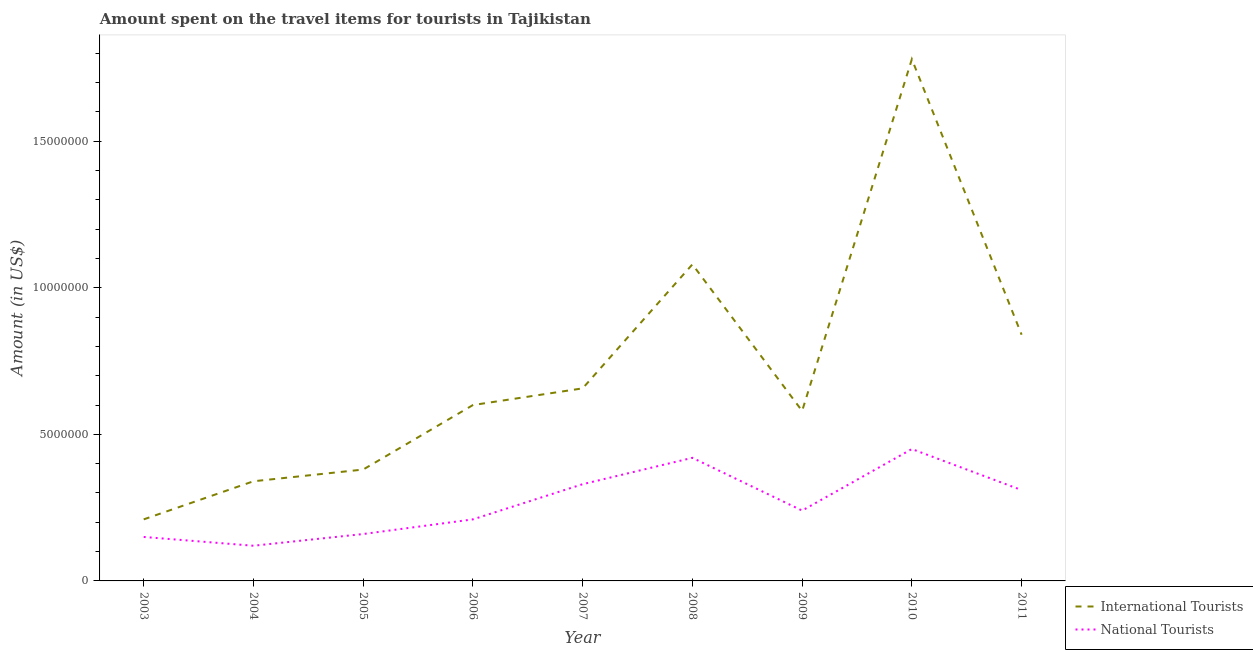Is the number of lines equal to the number of legend labels?
Your answer should be very brief. Yes. What is the amount spent on travel items of national tourists in 2004?
Provide a succinct answer. 1.20e+06. Across all years, what is the maximum amount spent on travel items of national tourists?
Provide a succinct answer. 4.50e+06. Across all years, what is the minimum amount spent on travel items of international tourists?
Offer a very short reply. 2.10e+06. In which year was the amount spent on travel items of international tourists minimum?
Give a very brief answer. 2003. What is the total amount spent on travel items of international tourists in the graph?
Give a very brief answer. 6.47e+07. What is the difference between the amount spent on travel items of international tourists in 2004 and that in 2009?
Your answer should be compact. -2.40e+06. What is the difference between the amount spent on travel items of international tourists in 2003 and the amount spent on travel items of national tourists in 2009?
Offer a terse response. -3.00e+05. What is the average amount spent on travel items of national tourists per year?
Offer a terse response. 2.66e+06. In the year 2007, what is the difference between the amount spent on travel items of national tourists and amount spent on travel items of international tourists?
Ensure brevity in your answer.  -3.27e+06. What is the ratio of the amount spent on travel items of national tourists in 2006 to that in 2010?
Keep it short and to the point. 0.47. Is the difference between the amount spent on travel items of international tourists in 2003 and 2011 greater than the difference between the amount spent on travel items of national tourists in 2003 and 2011?
Your response must be concise. No. What is the difference between the highest and the second highest amount spent on travel items of international tourists?
Your response must be concise. 7.00e+06. What is the difference between the highest and the lowest amount spent on travel items of international tourists?
Provide a succinct answer. 1.57e+07. Does the amount spent on travel items of international tourists monotonically increase over the years?
Your response must be concise. No. How many years are there in the graph?
Your response must be concise. 9. Does the graph contain grids?
Keep it short and to the point. No. How many legend labels are there?
Offer a very short reply. 2. What is the title of the graph?
Provide a short and direct response. Amount spent on the travel items for tourists in Tajikistan. What is the label or title of the X-axis?
Your answer should be very brief. Year. What is the label or title of the Y-axis?
Provide a succinct answer. Amount (in US$). What is the Amount (in US$) of International Tourists in 2003?
Keep it short and to the point. 2.10e+06. What is the Amount (in US$) in National Tourists in 2003?
Give a very brief answer. 1.50e+06. What is the Amount (in US$) of International Tourists in 2004?
Provide a short and direct response. 3.40e+06. What is the Amount (in US$) in National Tourists in 2004?
Keep it short and to the point. 1.20e+06. What is the Amount (in US$) of International Tourists in 2005?
Your answer should be very brief. 3.80e+06. What is the Amount (in US$) of National Tourists in 2005?
Your answer should be compact. 1.60e+06. What is the Amount (in US$) in National Tourists in 2006?
Provide a succinct answer. 2.10e+06. What is the Amount (in US$) in International Tourists in 2007?
Offer a terse response. 6.57e+06. What is the Amount (in US$) of National Tourists in 2007?
Your response must be concise. 3.30e+06. What is the Amount (in US$) in International Tourists in 2008?
Offer a very short reply. 1.08e+07. What is the Amount (in US$) in National Tourists in 2008?
Provide a short and direct response. 4.20e+06. What is the Amount (in US$) in International Tourists in 2009?
Offer a very short reply. 5.80e+06. What is the Amount (in US$) of National Tourists in 2009?
Give a very brief answer. 2.40e+06. What is the Amount (in US$) of International Tourists in 2010?
Provide a succinct answer. 1.78e+07. What is the Amount (in US$) in National Tourists in 2010?
Ensure brevity in your answer.  4.50e+06. What is the Amount (in US$) of International Tourists in 2011?
Offer a very short reply. 8.40e+06. What is the Amount (in US$) of National Tourists in 2011?
Your response must be concise. 3.10e+06. Across all years, what is the maximum Amount (in US$) in International Tourists?
Provide a short and direct response. 1.78e+07. Across all years, what is the maximum Amount (in US$) of National Tourists?
Your answer should be compact. 4.50e+06. Across all years, what is the minimum Amount (in US$) of International Tourists?
Your response must be concise. 2.10e+06. Across all years, what is the minimum Amount (in US$) in National Tourists?
Offer a terse response. 1.20e+06. What is the total Amount (in US$) in International Tourists in the graph?
Ensure brevity in your answer.  6.47e+07. What is the total Amount (in US$) in National Tourists in the graph?
Keep it short and to the point. 2.39e+07. What is the difference between the Amount (in US$) of International Tourists in 2003 and that in 2004?
Your answer should be very brief. -1.30e+06. What is the difference between the Amount (in US$) of International Tourists in 2003 and that in 2005?
Ensure brevity in your answer.  -1.70e+06. What is the difference between the Amount (in US$) of National Tourists in 2003 and that in 2005?
Your response must be concise. -1.00e+05. What is the difference between the Amount (in US$) in International Tourists in 2003 and that in 2006?
Give a very brief answer. -3.90e+06. What is the difference between the Amount (in US$) in National Tourists in 2003 and that in 2006?
Make the answer very short. -6.00e+05. What is the difference between the Amount (in US$) in International Tourists in 2003 and that in 2007?
Offer a terse response. -4.47e+06. What is the difference between the Amount (in US$) in National Tourists in 2003 and that in 2007?
Your answer should be compact. -1.80e+06. What is the difference between the Amount (in US$) of International Tourists in 2003 and that in 2008?
Ensure brevity in your answer.  -8.70e+06. What is the difference between the Amount (in US$) of National Tourists in 2003 and that in 2008?
Ensure brevity in your answer.  -2.70e+06. What is the difference between the Amount (in US$) in International Tourists in 2003 and that in 2009?
Give a very brief answer. -3.70e+06. What is the difference between the Amount (in US$) in National Tourists in 2003 and that in 2009?
Keep it short and to the point. -9.00e+05. What is the difference between the Amount (in US$) in International Tourists in 2003 and that in 2010?
Make the answer very short. -1.57e+07. What is the difference between the Amount (in US$) of International Tourists in 2003 and that in 2011?
Keep it short and to the point. -6.30e+06. What is the difference between the Amount (in US$) of National Tourists in 2003 and that in 2011?
Offer a terse response. -1.60e+06. What is the difference between the Amount (in US$) of International Tourists in 2004 and that in 2005?
Provide a short and direct response. -4.00e+05. What is the difference between the Amount (in US$) of National Tourists in 2004 and that in 2005?
Your answer should be very brief. -4.00e+05. What is the difference between the Amount (in US$) in International Tourists in 2004 and that in 2006?
Make the answer very short. -2.60e+06. What is the difference between the Amount (in US$) in National Tourists in 2004 and that in 2006?
Your answer should be very brief. -9.00e+05. What is the difference between the Amount (in US$) of International Tourists in 2004 and that in 2007?
Ensure brevity in your answer.  -3.17e+06. What is the difference between the Amount (in US$) in National Tourists in 2004 and that in 2007?
Offer a terse response. -2.10e+06. What is the difference between the Amount (in US$) in International Tourists in 2004 and that in 2008?
Give a very brief answer. -7.40e+06. What is the difference between the Amount (in US$) of International Tourists in 2004 and that in 2009?
Ensure brevity in your answer.  -2.40e+06. What is the difference between the Amount (in US$) of National Tourists in 2004 and that in 2009?
Ensure brevity in your answer.  -1.20e+06. What is the difference between the Amount (in US$) of International Tourists in 2004 and that in 2010?
Keep it short and to the point. -1.44e+07. What is the difference between the Amount (in US$) of National Tourists in 2004 and that in 2010?
Give a very brief answer. -3.30e+06. What is the difference between the Amount (in US$) of International Tourists in 2004 and that in 2011?
Keep it short and to the point. -5.00e+06. What is the difference between the Amount (in US$) of National Tourists in 2004 and that in 2011?
Provide a succinct answer. -1.90e+06. What is the difference between the Amount (in US$) of International Tourists in 2005 and that in 2006?
Offer a very short reply. -2.20e+06. What is the difference between the Amount (in US$) in National Tourists in 2005 and that in 2006?
Your answer should be compact. -5.00e+05. What is the difference between the Amount (in US$) in International Tourists in 2005 and that in 2007?
Keep it short and to the point. -2.77e+06. What is the difference between the Amount (in US$) in National Tourists in 2005 and that in 2007?
Offer a terse response. -1.70e+06. What is the difference between the Amount (in US$) of International Tourists in 2005 and that in 2008?
Offer a terse response. -7.00e+06. What is the difference between the Amount (in US$) of National Tourists in 2005 and that in 2008?
Your answer should be compact. -2.60e+06. What is the difference between the Amount (in US$) of International Tourists in 2005 and that in 2009?
Give a very brief answer. -2.00e+06. What is the difference between the Amount (in US$) in National Tourists in 2005 and that in 2009?
Your response must be concise. -8.00e+05. What is the difference between the Amount (in US$) of International Tourists in 2005 and that in 2010?
Offer a terse response. -1.40e+07. What is the difference between the Amount (in US$) of National Tourists in 2005 and that in 2010?
Your answer should be compact. -2.90e+06. What is the difference between the Amount (in US$) of International Tourists in 2005 and that in 2011?
Offer a terse response. -4.60e+06. What is the difference between the Amount (in US$) of National Tourists in 2005 and that in 2011?
Make the answer very short. -1.50e+06. What is the difference between the Amount (in US$) of International Tourists in 2006 and that in 2007?
Offer a terse response. -5.70e+05. What is the difference between the Amount (in US$) in National Tourists in 2006 and that in 2007?
Make the answer very short. -1.20e+06. What is the difference between the Amount (in US$) in International Tourists in 2006 and that in 2008?
Offer a very short reply. -4.80e+06. What is the difference between the Amount (in US$) in National Tourists in 2006 and that in 2008?
Make the answer very short. -2.10e+06. What is the difference between the Amount (in US$) in International Tourists in 2006 and that in 2009?
Keep it short and to the point. 2.00e+05. What is the difference between the Amount (in US$) of International Tourists in 2006 and that in 2010?
Provide a succinct answer. -1.18e+07. What is the difference between the Amount (in US$) of National Tourists in 2006 and that in 2010?
Offer a terse response. -2.40e+06. What is the difference between the Amount (in US$) of International Tourists in 2006 and that in 2011?
Give a very brief answer. -2.40e+06. What is the difference between the Amount (in US$) in International Tourists in 2007 and that in 2008?
Ensure brevity in your answer.  -4.23e+06. What is the difference between the Amount (in US$) in National Tourists in 2007 and that in 2008?
Provide a short and direct response. -9.00e+05. What is the difference between the Amount (in US$) in International Tourists in 2007 and that in 2009?
Ensure brevity in your answer.  7.70e+05. What is the difference between the Amount (in US$) of International Tourists in 2007 and that in 2010?
Provide a short and direct response. -1.12e+07. What is the difference between the Amount (in US$) in National Tourists in 2007 and that in 2010?
Your answer should be very brief. -1.20e+06. What is the difference between the Amount (in US$) of International Tourists in 2007 and that in 2011?
Ensure brevity in your answer.  -1.83e+06. What is the difference between the Amount (in US$) in National Tourists in 2007 and that in 2011?
Your response must be concise. 2.00e+05. What is the difference between the Amount (in US$) in National Tourists in 2008 and that in 2009?
Provide a succinct answer. 1.80e+06. What is the difference between the Amount (in US$) of International Tourists in 2008 and that in 2010?
Provide a succinct answer. -7.00e+06. What is the difference between the Amount (in US$) of International Tourists in 2008 and that in 2011?
Ensure brevity in your answer.  2.40e+06. What is the difference between the Amount (in US$) in National Tourists in 2008 and that in 2011?
Keep it short and to the point. 1.10e+06. What is the difference between the Amount (in US$) of International Tourists in 2009 and that in 2010?
Your answer should be compact. -1.20e+07. What is the difference between the Amount (in US$) in National Tourists in 2009 and that in 2010?
Make the answer very short. -2.10e+06. What is the difference between the Amount (in US$) of International Tourists in 2009 and that in 2011?
Your response must be concise. -2.60e+06. What is the difference between the Amount (in US$) in National Tourists in 2009 and that in 2011?
Your response must be concise. -7.00e+05. What is the difference between the Amount (in US$) in International Tourists in 2010 and that in 2011?
Keep it short and to the point. 9.40e+06. What is the difference between the Amount (in US$) in National Tourists in 2010 and that in 2011?
Your response must be concise. 1.40e+06. What is the difference between the Amount (in US$) of International Tourists in 2003 and the Amount (in US$) of National Tourists in 2004?
Give a very brief answer. 9.00e+05. What is the difference between the Amount (in US$) in International Tourists in 2003 and the Amount (in US$) in National Tourists in 2005?
Provide a succinct answer. 5.00e+05. What is the difference between the Amount (in US$) in International Tourists in 2003 and the Amount (in US$) in National Tourists in 2006?
Provide a succinct answer. 0. What is the difference between the Amount (in US$) of International Tourists in 2003 and the Amount (in US$) of National Tourists in 2007?
Keep it short and to the point. -1.20e+06. What is the difference between the Amount (in US$) in International Tourists in 2003 and the Amount (in US$) in National Tourists in 2008?
Provide a short and direct response. -2.10e+06. What is the difference between the Amount (in US$) in International Tourists in 2003 and the Amount (in US$) in National Tourists in 2009?
Your answer should be compact. -3.00e+05. What is the difference between the Amount (in US$) of International Tourists in 2003 and the Amount (in US$) of National Tourists in 2010?
Keep it short and to the point. -2.40e+06. What is the difference between the Amount (in US$) of International Tourists in 2004 and the Amount (in US$) of National Tourists in 2005?
Make the answer very short. 1.80e+06. What is the difference between the Amount (in US$) of International Tourists in 2004 and the Amount (in US$) of National Tourists in 2006?
Your answer should be very brief. 1.30e+06. What is the difference between the Amount (in US$) of International Tourists in 2004 and the Amount (in US$) of National Tourists in 2007?
Give a very brief answer. 1.00e+05. What is the difference between the Amount (in US$) in International Tourists in 2004 and the Amount (in US$) in National Tourists in 2008?
Ensure brevity in your answer.  -8.00e+05. What is the difference between the Amount (in US$) in International Tourists in 2004 and the Amount (in US$) in National Tourists in 2010?
Provide a short and direct response. -1.10e+06. What is the difference between the Amount (in US$) of International Tourists in 2005 and the Amount (in US$) of National Tourists in 2006?
Keep it short and to the point. 1.70e+06. What is the difference between the Amount (in US$) in International Tourists in 2005 and the Amount (in US$) in National Tourists in 2008?
Ensure brevity in your answer.  -4.00e+05. What is the difference between the Amount (in US$) of International Tourists in 2005 and the Amount (in US$) of National Tourists in 2009?
Keep it short and to the point. 1.40e+06. What is the difference between the Amount (in US$) in International Tourists in 2005 and the Amount (in US$) in National Tourists in 2010?
Your answer should be very brief. -7.00e+05. What is the difference between the Amount (in US$) in International Tourists in 2006 and the Amount (in US$) in National Tourists in 2007?
Your answer should be compact. 2.70e+06. What is the difference between the Amount (in US$) in International Tourists in 2006 and the Amount (in US$) in National Tourists in 2008?
Offer a terse response. 1.80e+06. What is the difference between the Amount (in US$) in International Tourists in 2006 and the Amount (in US$) in National Tourists in 2009?
Keep it short and to the point. 3.60e+06. What is the difference between the Amount (in US$) in International Tourists in 2006 and the Amount (in US$) in National Tourists in 2010?
Give a very brief answer. 1.50e+06. What is the difference between the Amount (in US$) of International Tourists in 2006 and the Amount (in US$) of National Tourists in 2011?
Give a very brief answer. 2.90e+06. What is the difference between the Amount (in US$) of International Tourists in 2007 and the Amount (in US$) of National Tourists in 2008?
Make the answer very short. 2.37e+06. What is the difference between the Amount (in US$) of International Tourists in 2007 and the Amount (in US$) of National Tourists in 2009?
Keep it short and to the point. 4.17e+06. What is the difference between the Amount (in US$) of International Tourists in 2007 and the Amount (in US$) of National Tourists in 2010?
Keep it short and to the point. 2.07e+06. What is the difference between the Amount (in US$) of International Tourists in 2007 and the Amount (in US$) of National Tourists in 2011?
Ensure brevity in your answer.  3.47e+06. What is the difference between the Amount (in US$) in International Tourists in 2008 and the Amount (in US$) in National Tourists in 2009?
Your response must be concise. 8.40e+06. What is the difference between the Amount (in US$) of International Tourists in 2008 and the Amount (in US$) of National Tourists in 2010?
Ensure brevity in your answer.  6.30e+06. What is the difference between the Amount (in US$) of International Tourists in 2008 and the Amount (in US$) of National Tourists in 2011?
Ensure brevity in your answer.  7.70e+06. What is the difference between the Amount (in US$) in International Tourists in 2009 and the Amount (in US$) in National Tourists in 2010?
Offer a very short reply. 1.30e+06. What is the difference between the Amount (in US$) of International Tourists in 2009 and the Amount (in US$) of National Tourists in 2011?
Ensure brevity in your answer.  2.70e+06. What is the difference between the Amount (in US$) of International Tourists in 2010 and the Amount (in US$) of National Tourists in 2011?
Your answer should be compact. 1.47e+07. What is the average Amount (in US$) in International Tourists per year?
Your answer should be very brief. 7.19e+06. What is the average Amount (in US$) of National Tourists per year?
Give a very brief answer. 2.66e+06. In the year 2004, what is the difference between the Amount (in US$) in International Tourists and Amount (in US$) in National Tourists?
Make the answer very short. 2.20e+06. In the year 2005, what is the difference between the Amount (in US$) in International Tourists and Amount (in US$) in National Tourists?
Keep it short and to the point. 2.20e+06. In the year 2006, what is the difference between the Amount (in US$) in International Tourists and Amount (in US$) in National Tourists?
Give a very brief answer. 3.90e+06. In the year 2007, what is the difference between the Amount (in US$) in International Tourists and Amount (in US$) in National Tourists?
Provide a short and direct response. 3.27e+06. In the year 2008, what is the difference between the Amount (in US$) in International Tourists and Amount (in US$) in National Tourists?
Give a very brief answer. 6.60e+06. In the year 2009, what is the difference between the Amount (in US$) in International Tourists and Amount (in US$) in National Tourists?
Ensure brevity in your answer.  3.40e+06. In the year 2010, what is the difference between the Amount (in US$) of International Tourists and Amount (in US$) of National Tourists?
Make the answer very short. 1.33e+07. In the year 2011, what is the difference between the Amount (in US$) of International Tourists and Amount (in US$) of National Tourists?
Your answer should be compact. 5.30e+06. What is the ratio of the Amount (in US$) of International Tourists in 2003 to that in 2004?
Provide a succinct answer. 0.62. What is the ratio of the Amount (in US$) of International Tourists in 2003 to that in 2005?
Your answer should be compact. 0.55. What is the ratio of the Amount (in US$) of National Tourists in 2003 to that in 2005?
Your response must be concise. 0.94. What is the ratio of the Amount (in US$) of International Tourists in 2003 to that in 2006?
Keep it short and to the point. 0.35. What is the ratio of the Amount (in US$) of International Tourists in 2003 to that in 2007?
Your response must be concise. 0.32. What is the ratio of the Amount (in US$) of National Tourists in 2003 to that in 2007?
Provide a succinct answer. 0.45. What is the ratio of the Amount (in US$) of International Tourists in 2003 to that in 2008?
Your response must be concise. 0.19. What is the ratio of the Amount (in US$) of National Tourists in 2003 to that in 2008?
Provide a short and direct response. 0.36. What is the ratio of the Amount (in US$) of International Tourists in 2003 to that in 2009?
Provide a succinct answer. 0.36. What is the ratio of the Amount (in US$) in International Tourists in 2003 to that in 2010?
Your response must be concise. 0.12. What is the ratio of the Amount (in US$) of National Tourists in 2003 to that in 2011?
Your response must be concise. 0.48. What is the ratio of the Amount (in US$) in International Tourists in 2004 to that in 2005?
Offer a very short reply. 0.89. What is the ratio of the Amount (in US$) in National Tourists in 2004 to that in 2005?
Give a very brief answer. 0.75. What is the ratio of the Amount (in US$) in International Tourists in 2004 to that in 2006?
Offer a very short reply. 0.57. What is the ratio of the Amount (in US$) in National Tourists in 2004 to that in 2006?
Offer a very short reply. 0.57. What is the ratio of the Amount (in US$) of International Tourists in 2004 to that in 2007?
Your answer should be very brief. 0.52. What is the ratio of the Amount (in US$) of National Tourists in 2004 to that in 2007?
Offer a terse response. 0.36. What is the ratio of the Amount (in US$) of International Tourists in 2004 to that in 2008?
Your answer should be very brief. 0.31. What is the ratio of the Amount (in US$) in National Tourists in 2004 to that in 2008?
Offer a terse response. 0.29. What is the ratio of the Amount (in US$) in International Tourists in 2004 to that in 2009?
Your answer should be very brief. 0.59. What is the ratio of the Amount (in US$) in National Tourists in 2004 to that in 2009?
Make the answer very short. 0.5. What is the ratio of the Amount (in US$) in International Tourists in 2004 to that in 2010?
Offer a very short reply. 0.19. What is the ratio of the Amount (in US$) in National Tourists in 2004 to that in 2010?
Make the answer very short. 0.27. What is the ratio of the Amount (in US$) of International Tourists in 2004 to that in 2011?
Give a very brief answer. 0.4. What is the ratio of the Amount (in US$) in National Tourists in 2004 to that in 2011?
Provide a short and direct response. 0.39. What is the ratio of the Amount (in US$) of International Tourists in 2005 to that in 2006?
Your answer should be compact. 0.63. What is the ratio of the Amount (in US$) of National Tourists in 2005 to that in 2006?
Keep it short and to the point. 0.76. What is the ratio of the Amount (in US$) in International Tourists in 2005 to that in 2007?
Keep it short and to the point. 0.58. What is the ratio of the Amount (in US$) in National Tourists in 2005 to that in 2007?
Your answer should be compact. 0.48. What is the ratio of the Amount (in US$) in International Tourists in 2005 to that in 2008?
Provide a succinct answer. 0.35. What is the ratio of the Amount (in US$) of National Tourists in 2005 to that in 2008?
Provide a succinct answer. 0.38. What is the ratio of the Amount (in US$) in International Tourists in 2005 to that in 2009?
Make the answer very short. 0.66. What is the ratio of the Amount (in US$) of National Tourists in 2005 to that in 2009?
Give a very brief answer. 0.67. What is the ratio of the Amount (in US$) of International Tourists in 2005 to that in 2010?
Make the answer very short. 0.21. What is the ratio of the Amount (in US$) in National Tourists in 2005 to that in 2010?
Give a very brief answer. 0.36. What is the ratio of the Amount (in US$) of International Tourists in 2005 to that in 2011?
Provide a succinct answer. 0.45. What is the ratio of the Amount (in US$) in National Tourists in 2005 to that in 2011?
Offer a very short reply. 0.52. What is the ratio of the Amount (in US$) in International Tourists in 2006 to that in 2007?
Ensure brevity in your answer.  0.91. What is the ratio of the Amount (in US$) in National Tourists in 2006 to that in 2007?
Make the answer very short. 0.64. What is the ratio of the Amount (in US$) of International Tourists in 2006 to that in 2008?
Keep it short and to the point. 0.56. What is the ratio of the Amount (in US$) in National Tourists in 2006 to that in 2008?
Give a very brief answer. 0.5. What is the ratio of the Amount (in US$) of International Tourists in 2006 to that in 2009?
Offer a very short reply. 1.03. What is the ratio of the Amount (in US$) in International Tourists in 2006 to that in 2010?
Offer a terse response. 0.34. What is the ratio of the Amount (in US$) in National Tourists in 2006 to that in 2010?
Offer a very short reply. 0.47. What is the ratio of the Amount (in US$) of International Tourists in 2006 to that in 2011?
Offer a terse response. 0.71. What is the ratio of the Amount (in US$) in National Tourists in 2006 to that in 2011?
Give a very brief answer. 0.68. What is the ratio of the Amount (in US$) in International Tourists in 2007 to that in 2008?
Provide a succinct answer. 0.61. What is the ratio of the Amount (in US$) in National Tourists in 2007 to that in 2008?
Ensure brevity in your answer.  0.79. What is the ratio of the Amount (in US$) of International Tourists in 2007 to that in 2009?
Provide a short and direct response. 1.13. What is the ratio of the Amount (in US$) of National Tourists in 2007 to that in 2009?
Your response must be concise. 1.38. What is the ratio of the Amount (in US$) in International Tourists in 2007 to that in 2010?
Offer a very short reply. 0.37. What is the ratio of the Amount (in US$) of National Tourists in 2007 to that in 2010?
Provide a succinct answer. 0.73. What is the ratio of the Amount (in US$) of International Tourists in 2007 to that in 2011?
Your answer should be compact. 0.78. What is the ratio of the Amount (in US$) in National Tourists in 2007 to that in 2011?
Give a very brief answer. 1.06. What is the ratio of the Amount (in US$) of International Tourists in 2008 to that in 2009?
Make the answer very short. 1.86. What is the ratio of the Amount (in US$) of National Tourists in 2008 to that in 2009?
Ensure brevity in your answer.  1.75. What is the ratio of the Amount (in US$) of International Tourists in 2008 to that in 2010?
Keep it short and to the point. 0.61. What is the ratio of the Amount (in US$) of International Tourists in 2008 to that in 2011?
Your answer should be very brief. 1.29. What is the ratio of the Amount (in US$) of National Tourists in 2008 to that in 2011?
Make the answer very short. 1.35. What is the ratio of the Amount (in US$) in International Tourists in 2009 to that in 2010?
Keep it short and to the point. 0.33. What is the ratio of the Amount (in US$) of National Tourists in 2009 to that in 2010?
Provide a short and direct response. 0.53. What is the ratio of the Amount (in US$) in International Tourists in 2009 to that in 2011?
Offer a terse response. 0.69. What is the ratio of the Amount (in US$) in National Tourists in 2009 to that in 2011?
Provide a succinct answer. 0.77. What is the ratio of the Amount (in US$) in International Tourists in 2010 to that in 2011?
Offer a very short reply. 2.12. What is the ratio of the Amount (in US$) in National Tourists in 2010 to that in 2011?
Offer a terse response. 1.45. What is the difference between the highest and the second highest Amount (in US$) of National Tourists?
Your answer should be very brief. 3.00e+05. What is the difference between the highest and the lowest Amount (in US$) of International Tourists?
Your answer should be compact. 1.57e+07. What is the difference between the highest and the lowest Amount (in US$) of National Tourists?
Provide a succinct answer. 3.30e+06. 